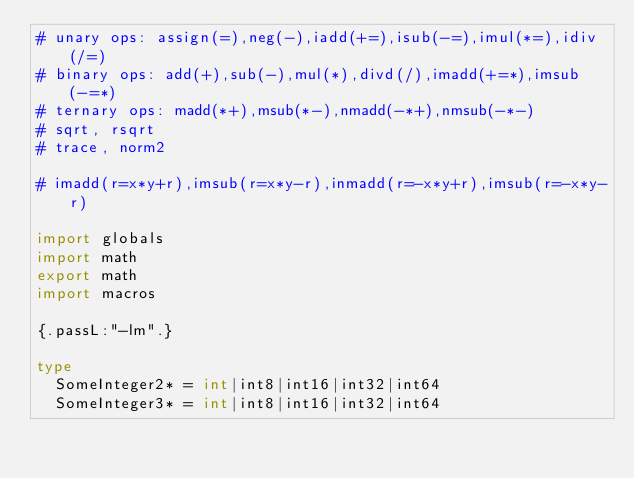<code> <loc_0><loc_0><loc_500><loc_500><_Nim_># unary ops: assign(=),neg(-),iadd(+=),isub(-=),imul(*=),idiv(/=)
# binary ops: add(+),sub(-),mul(*),divd(/),imadd(+=*),imsub(-=*)
# ternary ops: madd(*+),msub(*-),nmadd(-*+),nmsub(-*-)
# sqrt, rsqrt
# trace, norm2

# imadd(r=x*y+r),imsub(r=x*y-r),inmadd(r=-x*y+r),imsub(r=-x*y-r)

import globals
import math
export math
import macros

{.passL:"-lm".}

type
  SomeInteger2* = int|int8|int16|int32|int64
  SomeInteger3* = int|int8|int16|int32|int64</code> 